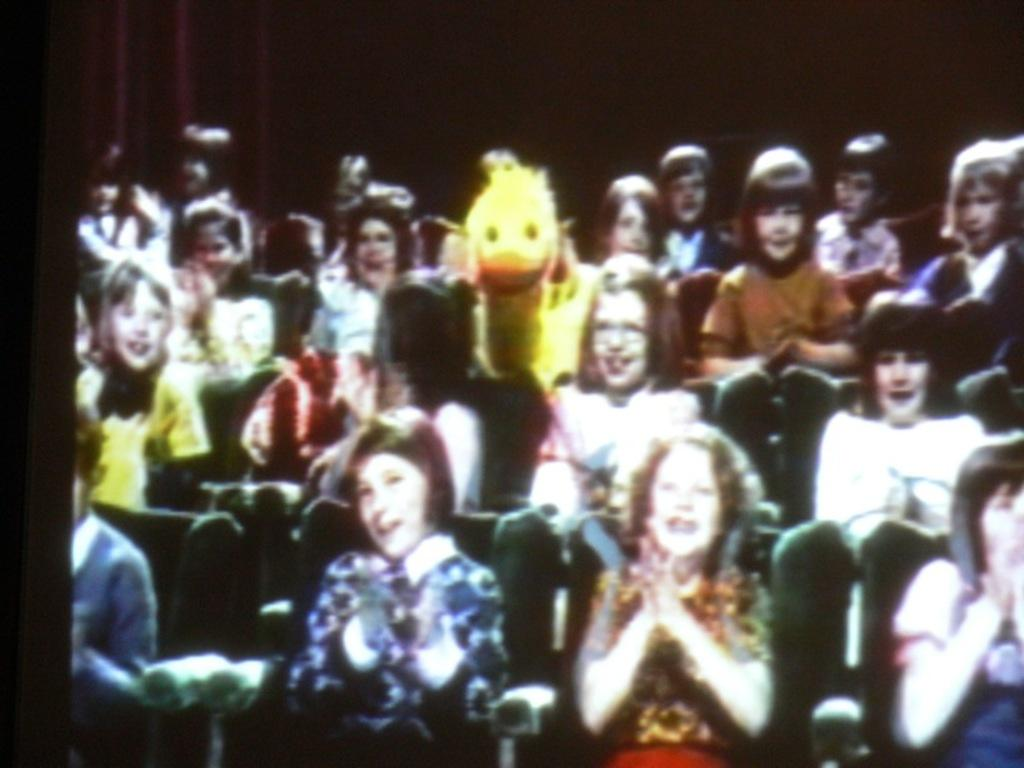What are the people in the image doing? The people in the image are sitting on chairs. What object is present in the middle of the chairs? There is a duck toy sitting in the middle of the chairs. How many pizzas are being served on the train in the image? There is no train or pizzas present in the image. What is the foot doing in the image? There is no foot present in the image. 